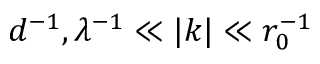Convert formula to latex. <formula><loc_0><loc_0><loc_500><loc_500>d ^ { - 1 } , \lambda ^ { - 1 } \ll | k | \ll r _ { 0 } ^ { - 1 }</formula> 